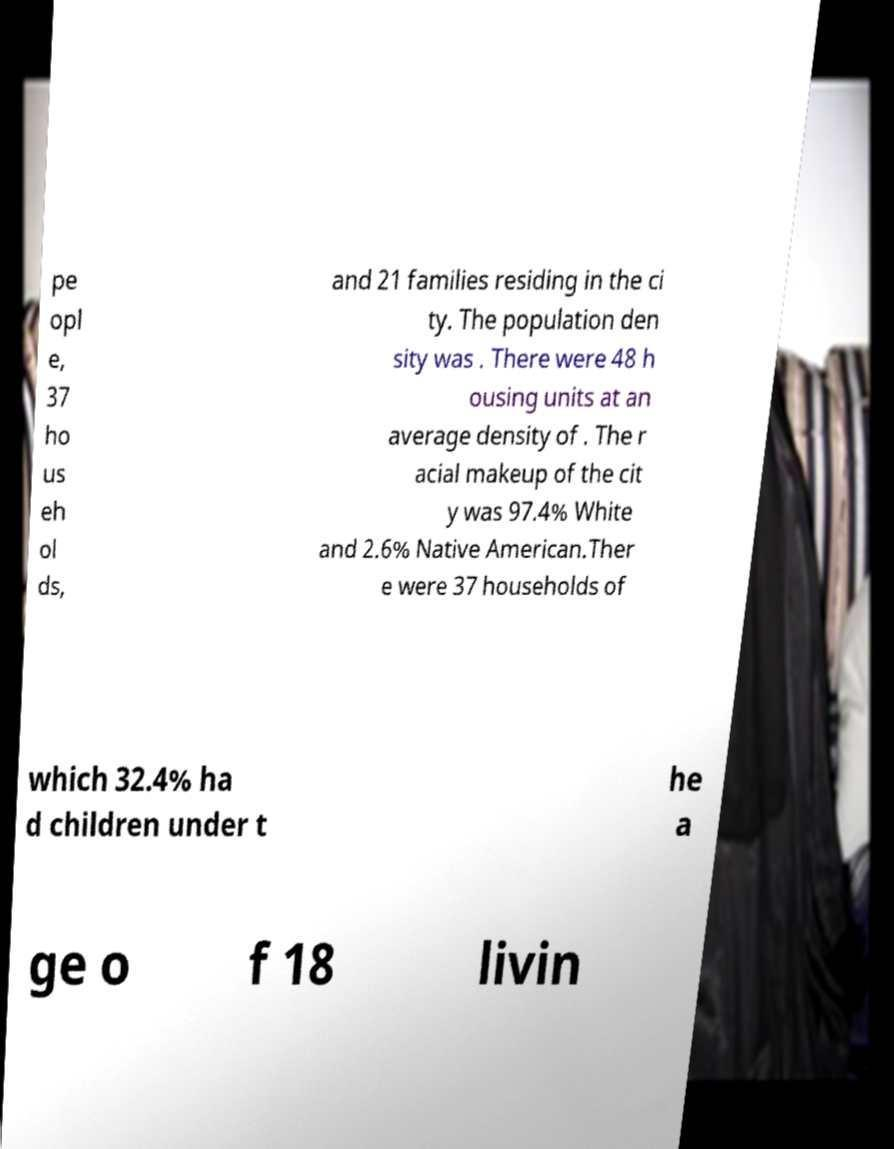There's text embedded in this image that I need extracted. Can you transcribe it verbatim? pe opl e, 37 ho us eh ol ds, and 21 families residing in the ci ty. The population den sity was . There were 48 h ousing units at an average density of . The r acial makeup of the cit y was 97.4% White and 2.6% Native American.Ther e were 37 households of which 32.4% ha d children under t he a ge o f 18 livin 